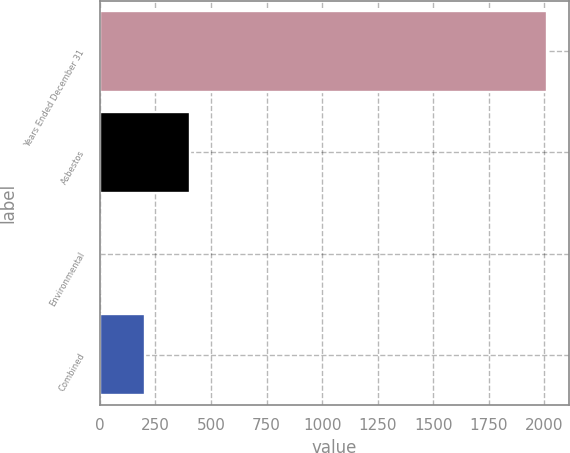Convert chart to OTSL. <chart><loc_0><loc_0><loc_500><loc_500><bar_chart><fcel>Years Ended December 31<fcel>Asbestos<fcel>Environmental<fcel>Combined<nl><fcel>2011<fcel>404.6<fcel>3<fcel>203.8<nl></chart> 